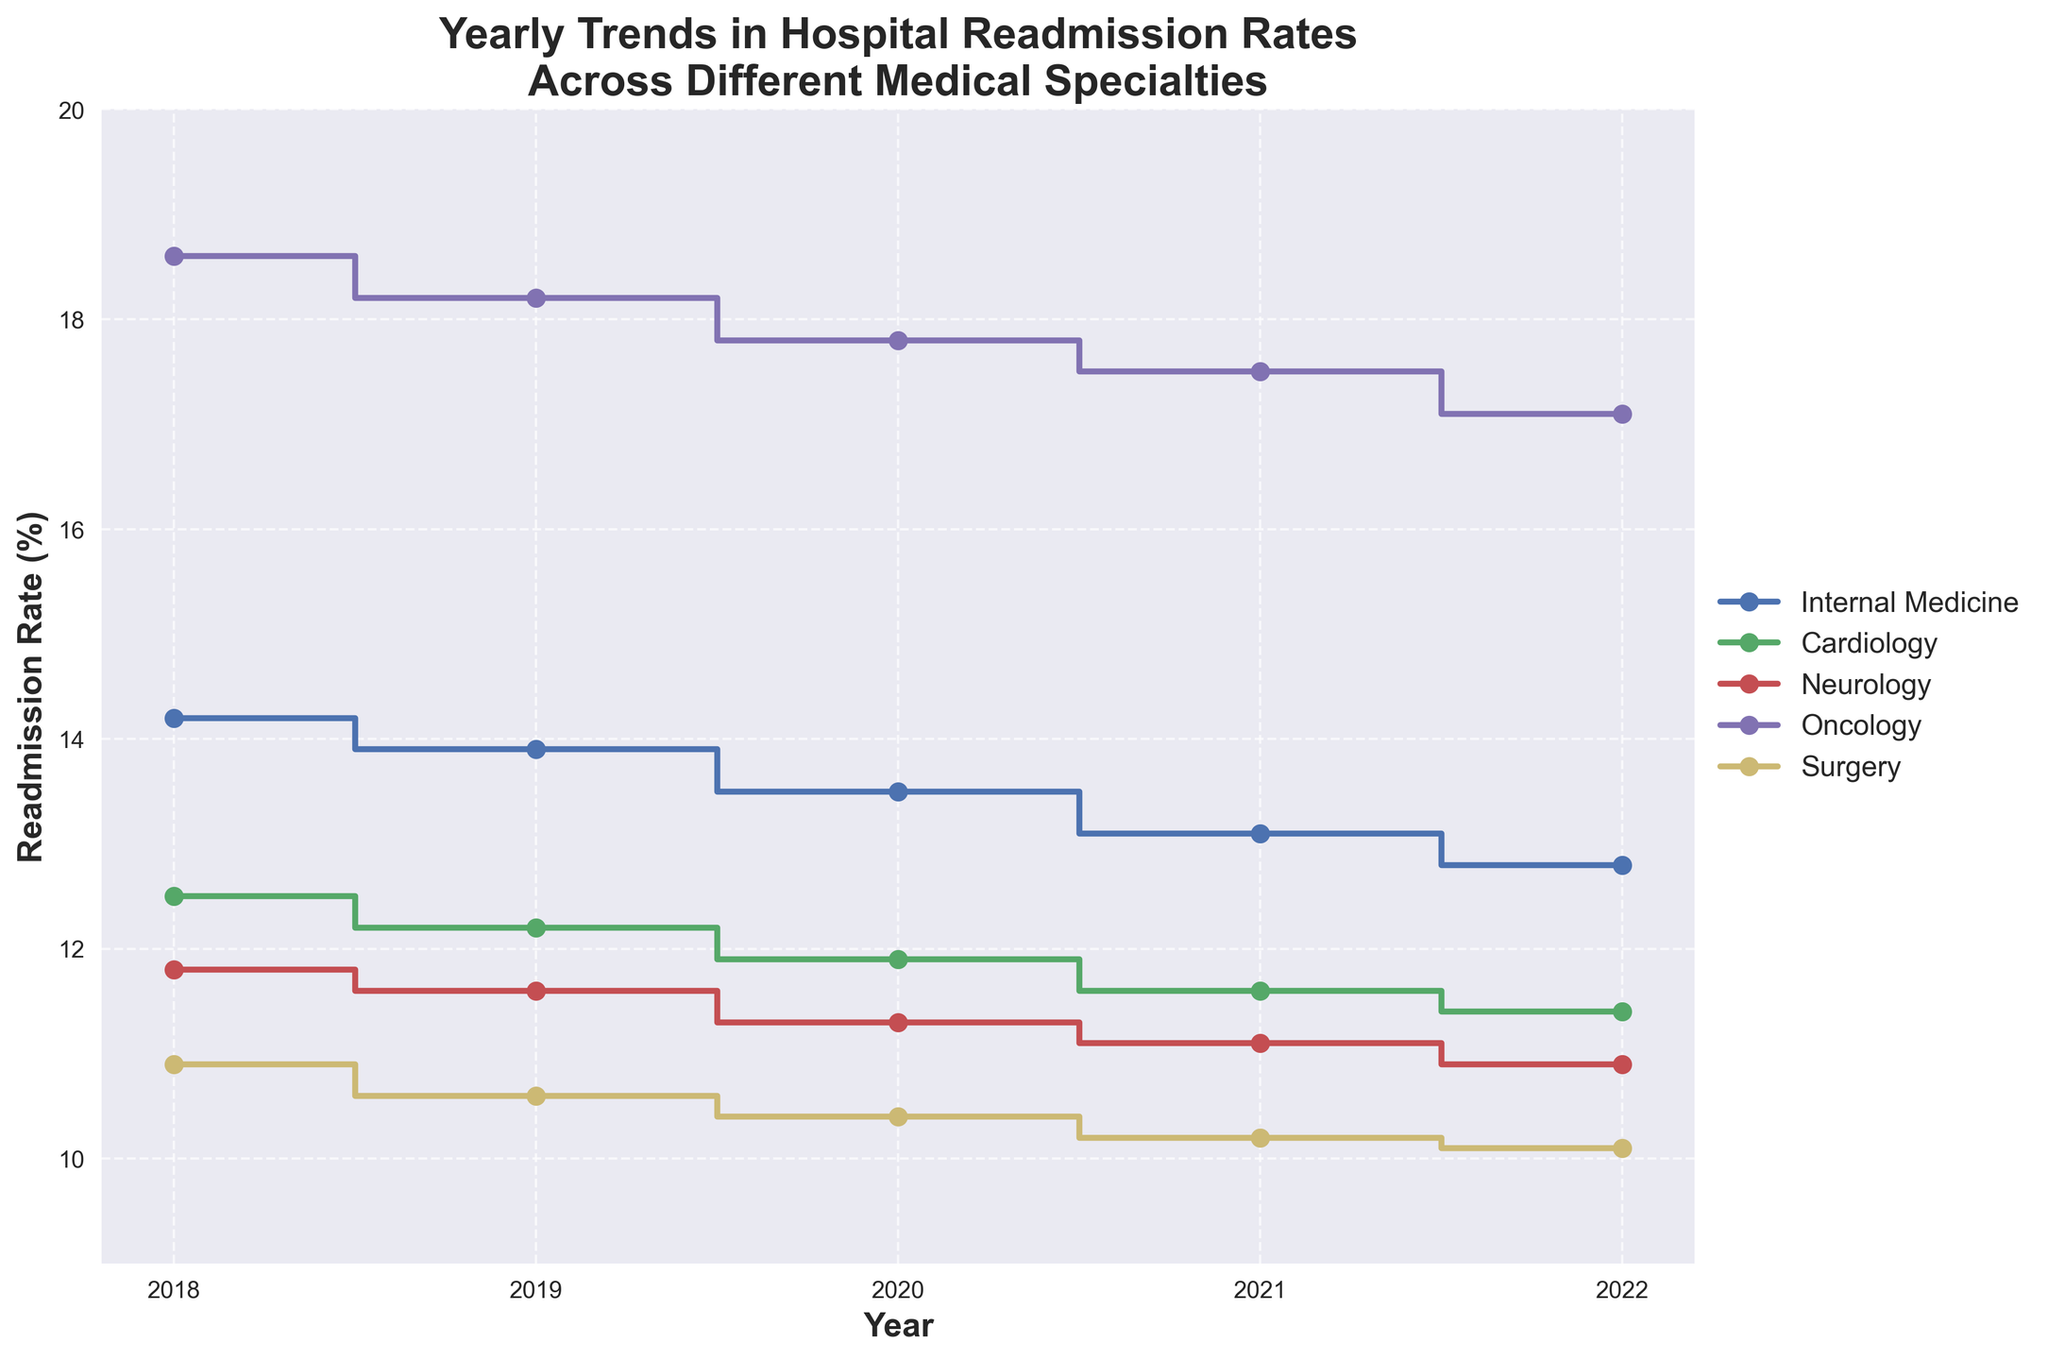What's the title of the figure? The title is presented at the top of the figure. It reads "Yearly Trends in Hospital Readmission Rates Across Different Medical Specialties".
Answer: Yearly Trends in Hospital Readmission Rates Across Different Medical Specialties Which medical specialty has the highest readmission rates in 2022? By looking at the figure for the year 2022, the highest readmission rate among the plotted specialties is for Oncology.
Answer: Oncology By how much did the readmission rate for Cardiology decrease from 2018 to 2022? First, identify the readmission rates for Cardiology in 2018 and 2022, which are 12.5% and 11.4% respectively. Then, calculate the difference: 12.5% - 11.4% = 1.1%.
Answer: 1.1% Which specialty showed the most significant decrease in readmission rates from 2018 to 2022? Calculate the differences in readmission rates between 2018 and 2022 for each specialty. The decreases are: 
- Internal Medicine: 14.2% - 12.8% = 1.4%
- Cardiology: 12.5% - 11.4% = 1.1%
- Neurology: 11.8% - 10.9% = 0.9%
- Oncology: 18.6% - 17.1% = 1.5%
- Surgery: 10.9% - 10.1% = 0.8%
The most significant decrease is for Oncology at 1.5%.
Answer: Oncology What's the overall trend in the readmission rates for Internal Medicine from 2018 to 2022? Observe the series of data points for Internal Medicine from 2018 to 2022. The values steadily decrease from 14.2% to 12.8%.
Answer: Decreasing Which two specialties had the closest readmission rates in 2021? Examine the data for 2021 and compare the readmission rates. In 2021, the rates were:
- Internal Medicine: 13.1%
- Cardiology: 11.6%
- Neurology: 11.1%
- Oncology: 17.5%
- Surgery: 10.2%
The closest values are for Cardiology (11.6%) and Neurology (11.1%), which have a difference of 0.5%.
Answer: Cardiology and Neurology What was the readmission rate for Neurology in 2020? Is it lower or higher than that of Cardiology for the same year? The readmission rate for Neurology in 2020 is retrieved from the data as 11.3%, and for Cardiology as 11.9%. Now, compare the two: 11.3% < 11.9%, so Neurology's rate is lower.
Answer: 11.3%, Lower What is the average readmission rate for Surgery from 2018 to 2022? Sum the readmission rates for Surgery for each year: 10.9% (2018), 10.6% (2019), 10.4% (2020), 10.2% (2021), and 10.1% (2022). The total is: 10.9% + 10.6% + 10.4% + 10.2% + 10.1% = 52.2%. Then, divide by the number of years: 52.2% / 5 = 10.44%.
Answer: 10.44% 